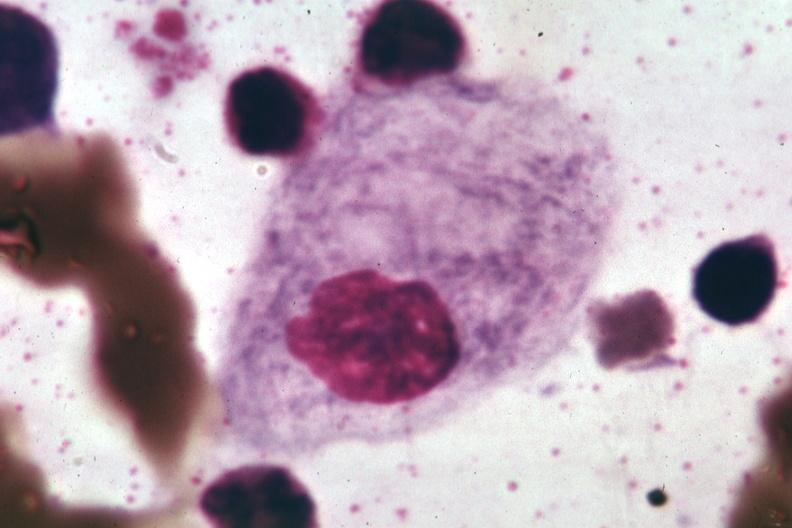s aorta present?
Answer the question using a single word or phrase. No 